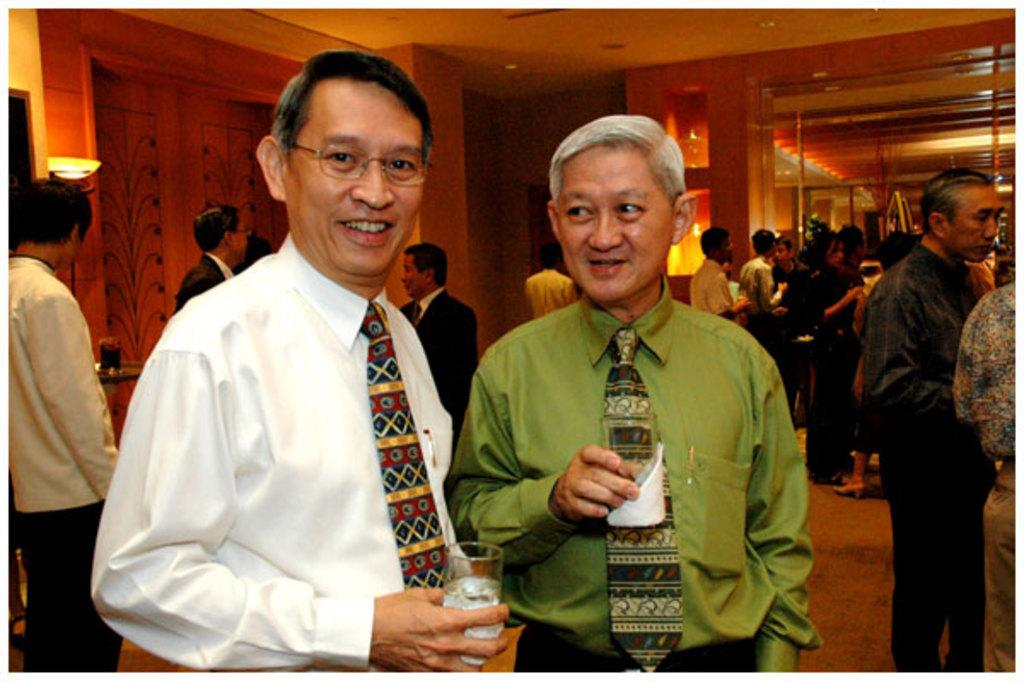What is the man doing in the image? The man is holding an object in the image. Can you describe the person holding an object in the image? There is a person holding an object in his hand in the image. Where is the box located in the image? The box is on a shelf in the image. What can be seen providing illumination in the image? There are lights visible in the image. Can you describe the dock in the image? There is no dock present in the image. What type of spark can be seen coming from the object held by the person in the image? There is no spark visible in the image; the object held by the person is not described as sparking. 